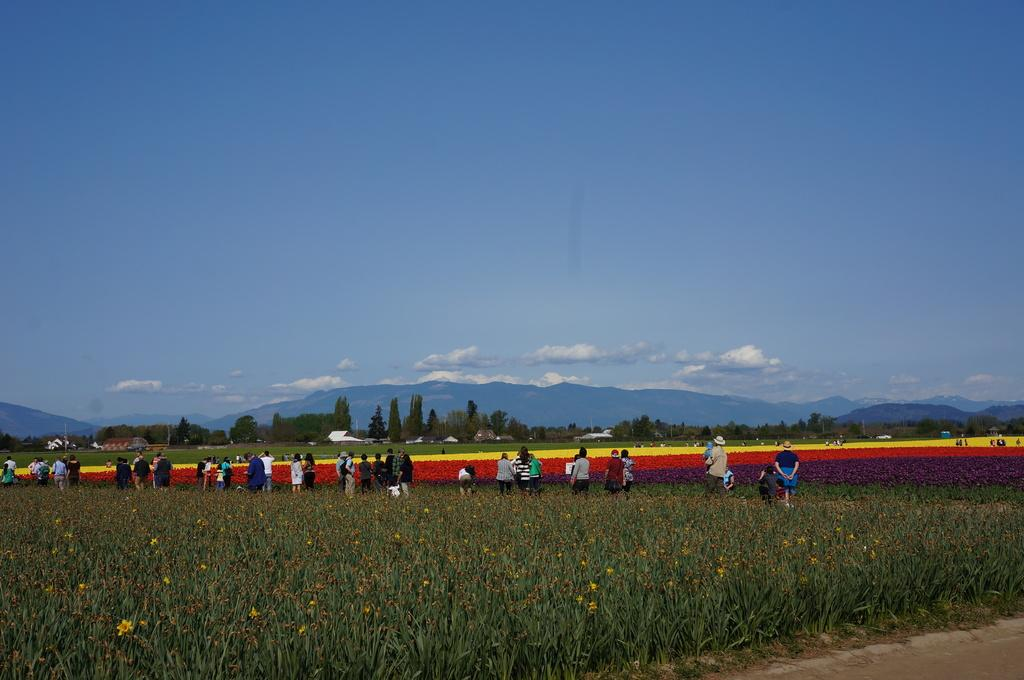What type of living organisms can be seen in the image? Plants are visible in the image. What can be seen in the background of the image? There are many people, flowers, trees, hills, and the sky visible in the background of the image. What is the condition of the sky in the image? The sky is visible in the background of the image, and there are clouds present. What type of structure can be seen supporting the pump in the image? There is no structure or pump present in the image. What type of trousers are the people in the background wearing? The provided facts do not mention the type of clothing the people in the background are wearing, so it cannot be determined from the image. 